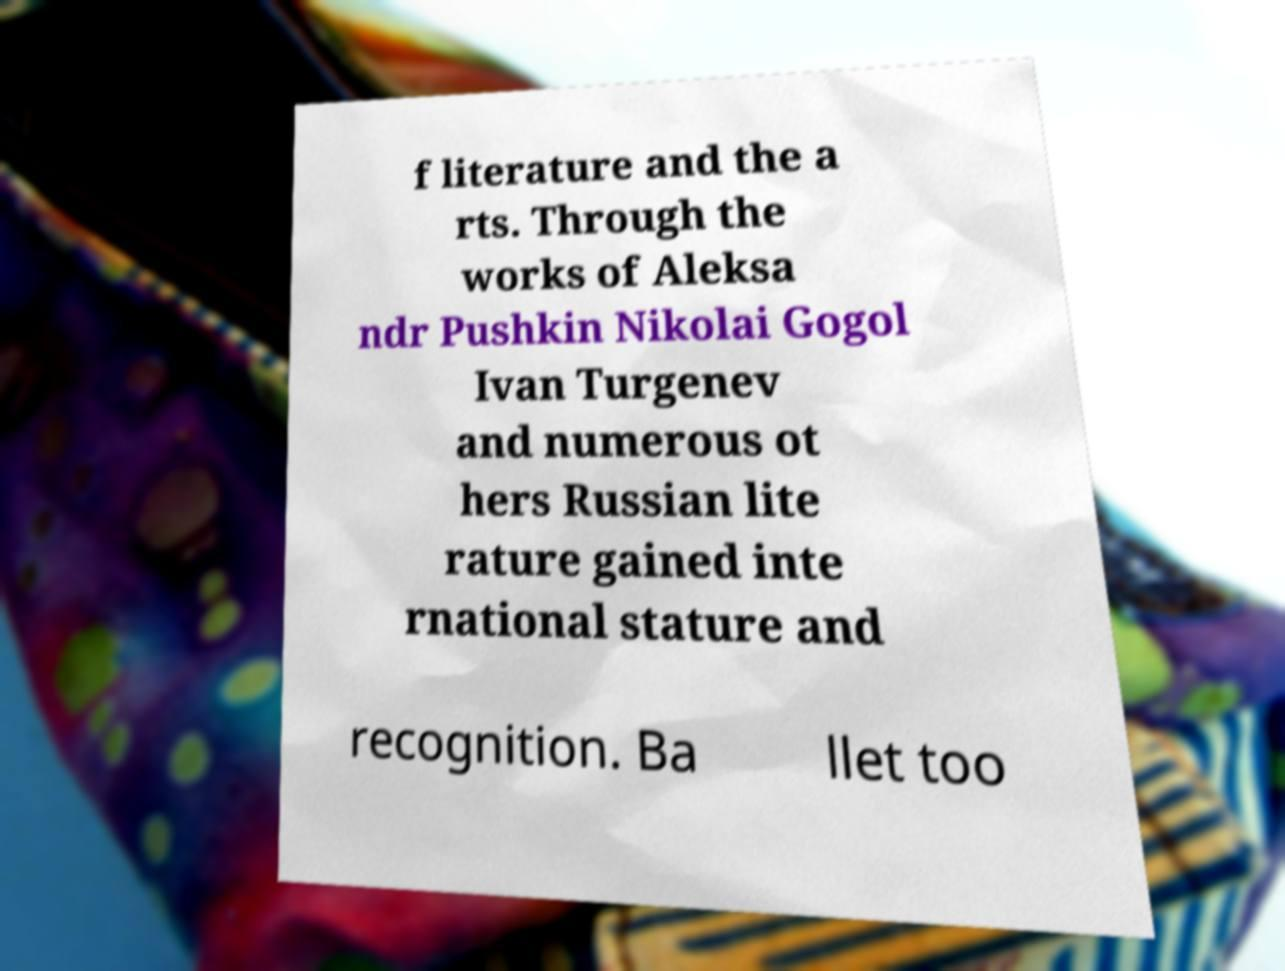There's text embedded in this image that I need extracted. Can you transcribe it verbatim? f literature and the a rts. Through the works of Aleksa ndr Pushkin Nikolai Gogol Ivan Turgenev and numerous ot hers Russian lite rature gained inte rnational stature and recognition. Ba llet too 